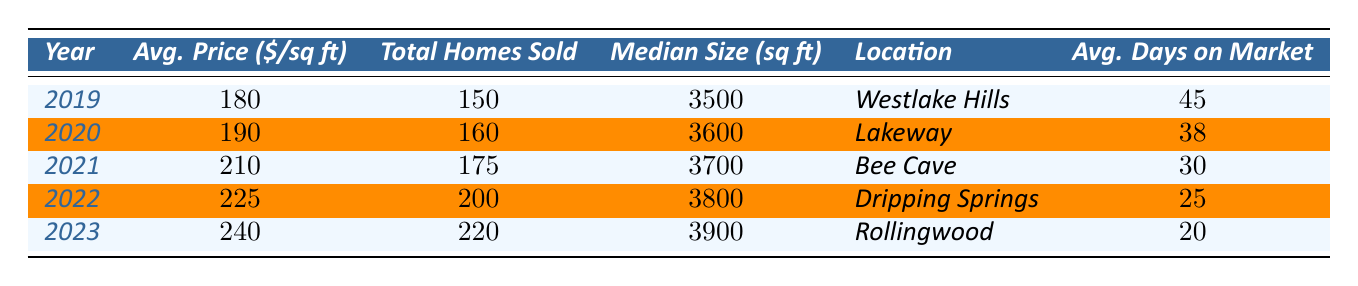What was the average price per square foot in 2021? Referring to the table, the average price per square foot in 2021 is listed in that row. It is 210.
Answer: 210 How many total custom homes were sold in 2022? By looking at the 2022 row in the table, the total number of custom homes sold is 200.
Answer: 200 Which year had the lowest average days on market? The average days on market decreases each year. 2019 has 45 days, while 2023 has 20 days, making 2023 the lowest.
Answer: 2023 What was the median home size in Dripping Springs? The median home size is found in the row corresponding to Dripping Springs. It is 3800 sq ft.
Answer: 3800 sq ft What was the average increase in price per square foot from 2019 to 2023? The average price per square foot in 2019 was 180, and in 2023 it was 240. The increase is 240 - 180 = 60 over 4 years, which averages to 60 / 4 = 15 per year.
Answer: 15 Did the average price decrease at any point between 2019 and 2023? Observing the average prices from the table, they all show an increasing trend from 180 to 240. Thus, there was no decrease.
Answer: No Which year sold the most custom homes, and what was the quantity? The data shows that 2023 has the highest number of homes sold at 220. This can be confirmed by comparing the totals from each year.
Answer: 2023, 220 What is the total number of custom homes sold from 2019 to 2023? To find the total, we need to sum the total homes sold from each year: 150 + 160 + 175 + 200 + 220 = 905.
Answer: 905 What was the median home size for the year with the highest average price per square foot? The year with the highest average price per square foot is 2023, which has an average price of 240. In 2023, the median home size is 3900 sq ft.
Answer: 3900 sq ft By how much did the average price per square foot increase from 2021 to 2022? The average price per square foot in 2021 was 210, and in 2022 it was 225. The difference is 225 - 210 = 15.
Answer: 15 